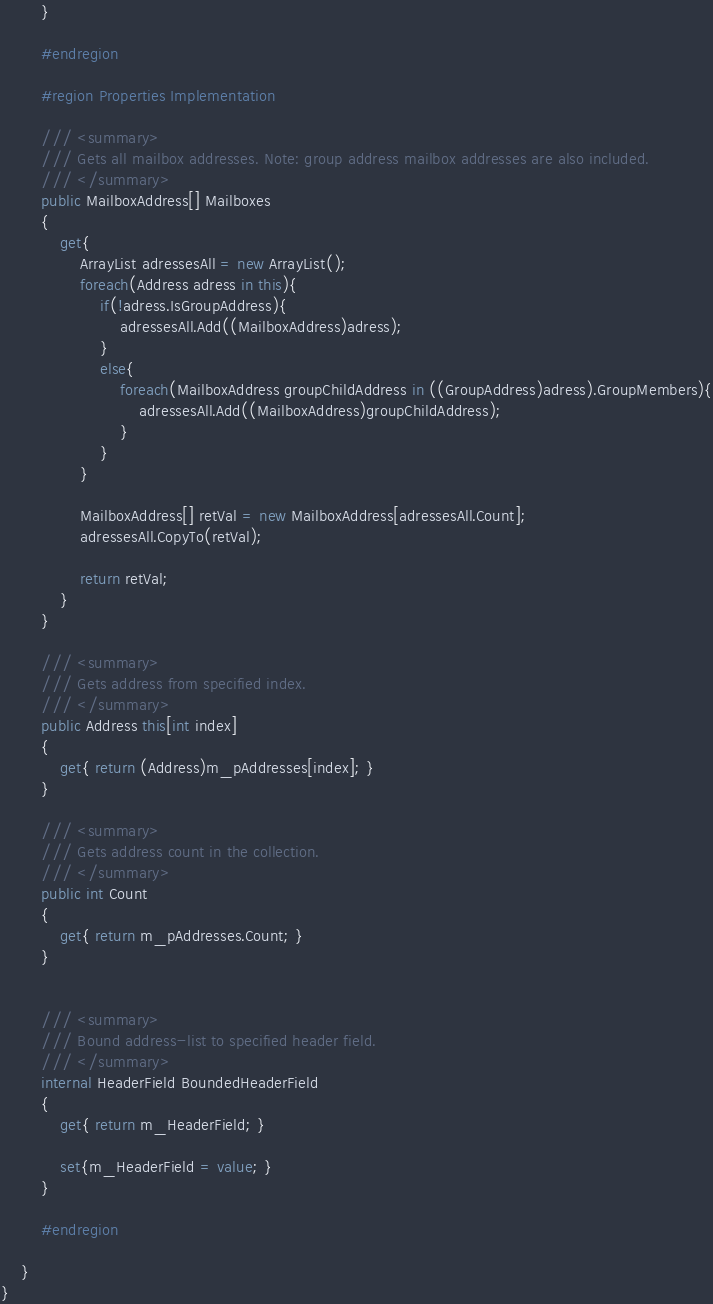<code> <loc_0><loc_0><loc_500><loc_500><_C#_>		}

		#endregion

		#region Properties Implementation

		/// <summary>
		/// Gets all mailbox addresses. Note: group address mailbox addresses are also included.
		/// </summary>
		public MailboxAddress[] Mailboxes
		{
			get{ 
				ArrayList adressesAll = new ArrayList();
				foreach(Address adress in this){
					if(!adress.IsGroupAddress){
						adressesAll.Add((MailboxAddress)adress);
					}
					else{
						foreach(MailboxAddress groupChildAddress in ((GroupAddress)adress).GroupMembers){
							adressesAll.Add((MailboxAddress)groupChildAddress);
						}
					}
				}

				MailboxAddress[] retVal = new MailboxAddress[adressesAll.Count];
				adressesAll.CopyTo(retVal);

				return retVal;
			}
		}

		/// <summary>
		/// Gets address from specified index.
		/// </summary>
		public Address this[int index]
		{
			get{ return (Address)m_pAddresses[index]; }
		}

		/// <summary>
		/// Gets address count in the collection.
		/// </summary>
		public int Count
		{
			get{ return m_pAddresses.Count; }
		}


		/// <summary>
		/// Bound address-list to specified header field.
		/// </summary>
		internal HeaderField BoundedHeaderField
		{
			get{ return m_HeaderField; }

			set{m_HeaderField = value; }
		}

		#endregion

	}
}
</code> 